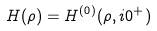Convert formula to latex. <formula><loc_0><loc_0><loc_500><loc_500>H ( \rho ) = H ^ { ( 0 ) } ( \rho , i 0 ^ { + } )</formula> 